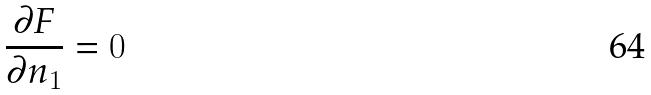Convert formula to latex. <formula><loc_0><loc_0><loc_500><loc_500>\frac { \partial F } { \partial n _ { 1 } } = 0</formula> 